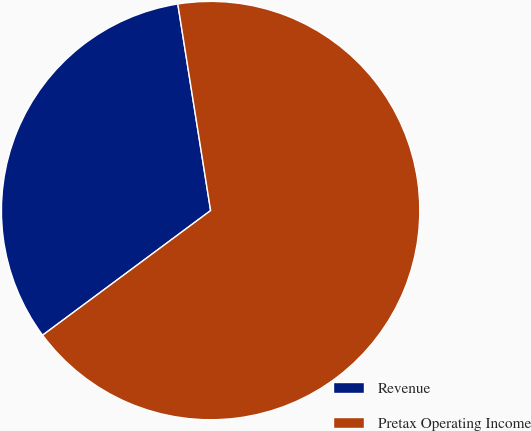Convert chart to OTSL. <chart><loc_0><loc_0><loc_500><loc_500><pie_chart><fcel>Revenue<fcel>Pretax Operating Income<nl><fcel>32.65%<fcel>67.35%<nl></chart> 